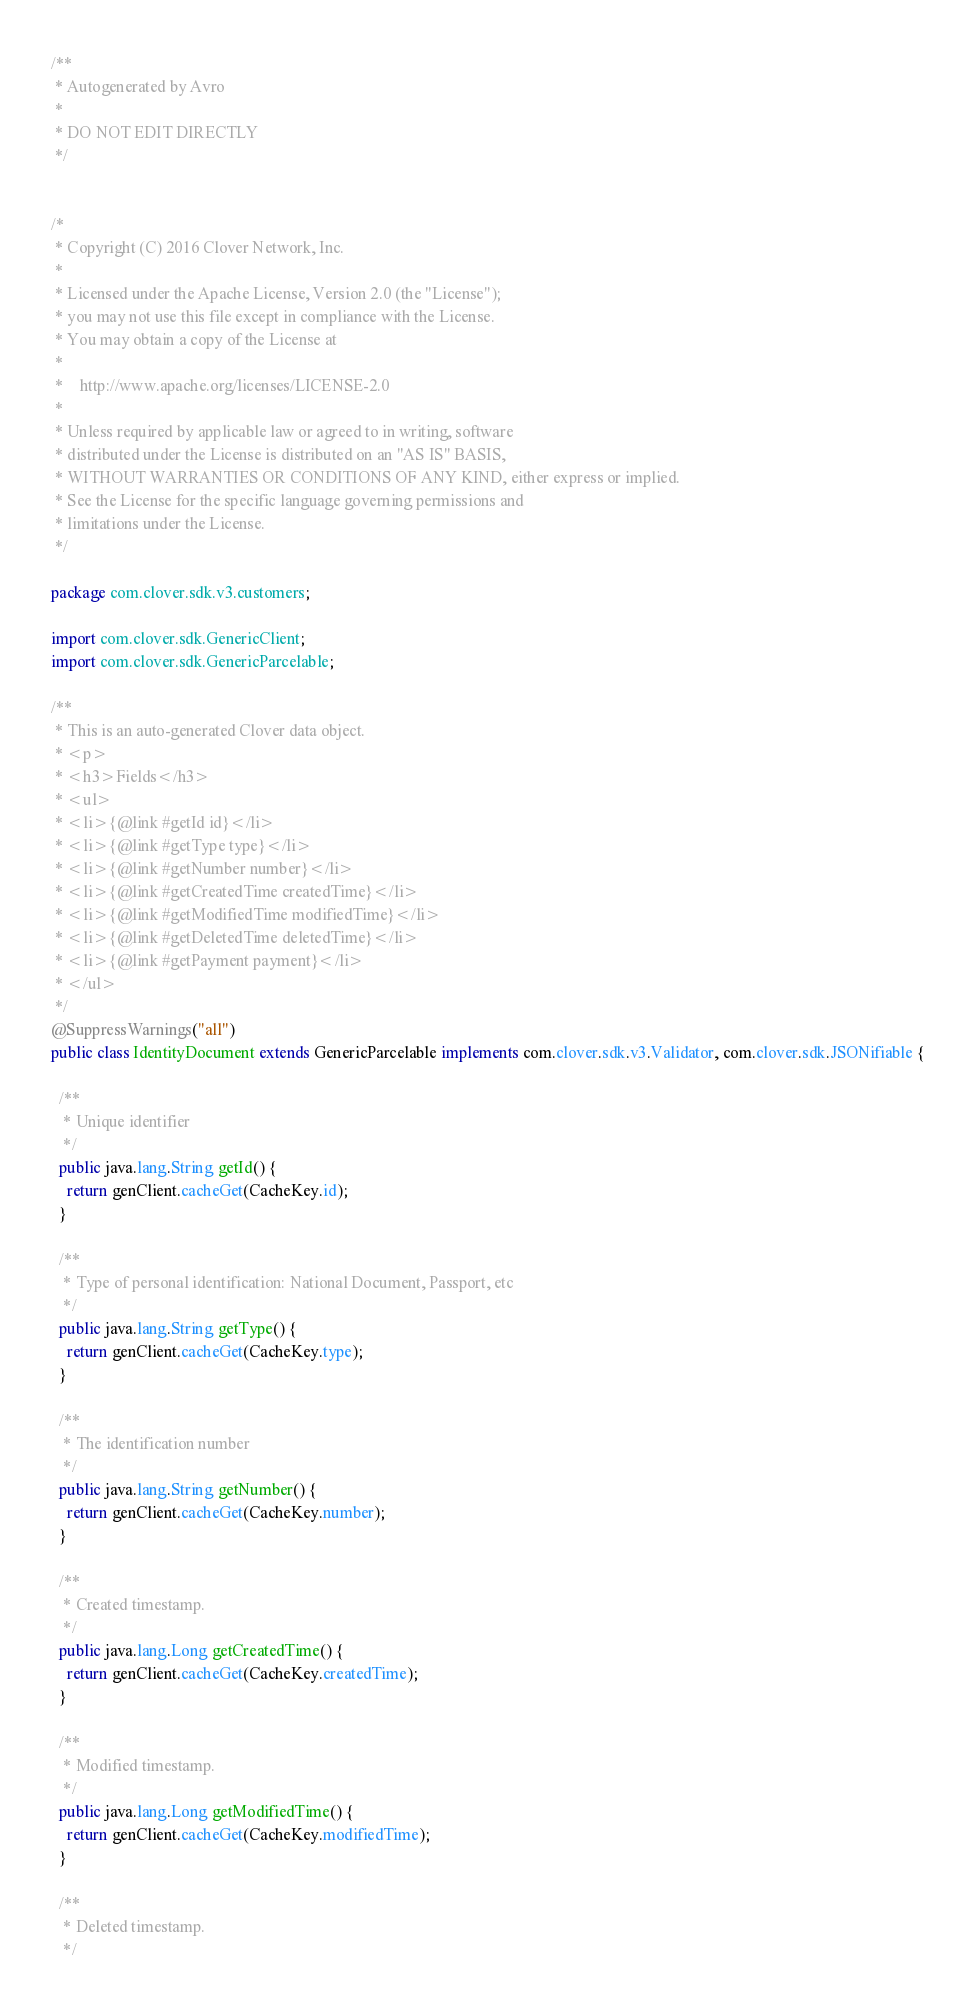Convert code to text. <code><loc_0><loc_0><loc_500><loc_500><_Java_>/**
 * Autogenerated by Avro
 *
 * DO NOT EDIT DIRECTLY
 */


/*
 * Copyright (C) 2016 Clover Network, Inc.
 *
 * Licensed under the Apache License, Version 2.0 (the "License");
 * you may not use this file except in compliance with the License.
 * You may obtain a copy of the License at
 *
 *    http://www.apache.org/licenses/LICENSE-2.0
 *
 * Unless required by applicable law or agreed to in writing, software
 * distributed under the License is distributed on an "AS IS" BASIS,
 * WITHOUT WARRANTIES OR CONDITIONS OF ANY KIND, either express or implied.
 * See the License for the specific language governing permissions and
 * limitations under the License.
 */

package com.clover.sdk.v3.customers;

import com.clover.sdk.GenericClient;
import com.clover.sdk.GenericParcelable;

/**
 * This is an auto-generated Clover data object.
 * <p>
 * <h3>Fields</h3>
 * <ul>
 * <li>{@link #getId id}</li>
 * <li>{@link #getType type}</li>
 * <li>{@link #getNumber number}</li>
 * <li>{@link #getCreatedTime createdTime}</li>
 * <li>{@link #getModifiedTime modifiedTime}</li>
 * <li>{@link #getDeletedTime deletedTime}</li>
 * <li>{@link #getPayment payment}</li>
 * </ul>
 */
@SuppressWarnings("all")
public class IdentityDocument extends GenericParcelable implements com.clover.sdk.v3.Validator, com.clover.sdk.JSONifiable {

  /**
   * Unique identifier
   */
  public java.lang.String getId() {
    return genClient.cacheGet(CacheKey.id);
  }

  /**
   * Type of personal identification: National Document, Passport, etc
   */
  public java.lang.String getType() {
    return genClient.cacheGet(CacheKey.type);
  }

  /**
   * The identification number
   */
  public java.lang.String getNumber() {
    return genClient.cacheGet(CacheKey.number);
  }

  /**
   * Created timestamp.
   */
  public java.lang.Long getCreatedTime() {
    return genClient.cacheGet(CacheKey.createdTime);
  }

  /**
   * Modified timestamp.
   */
  public java.lang.Long getModifiedTime() {
    return genClient.cacheGet(CacheKey.modifiedTime);
  }

  /**
   * Deleted timestamp.
   */</code> 